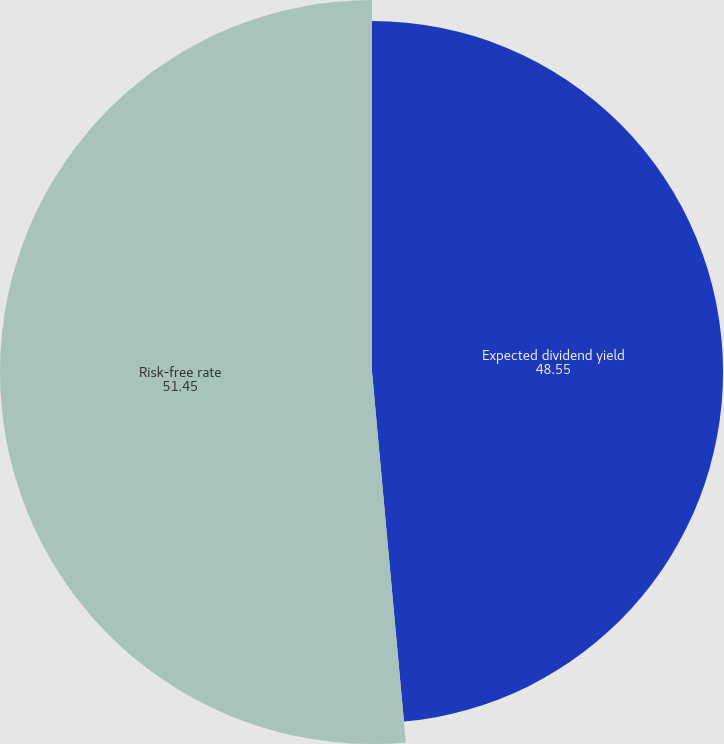<chart> <loc_0><loc_0><loc_500><loc_500><pie_chart><fcel>Expected dividend yield<fcel>Risk-free rate<nl><fcel>48.55%<fcel>51.45%<nl></chart> 